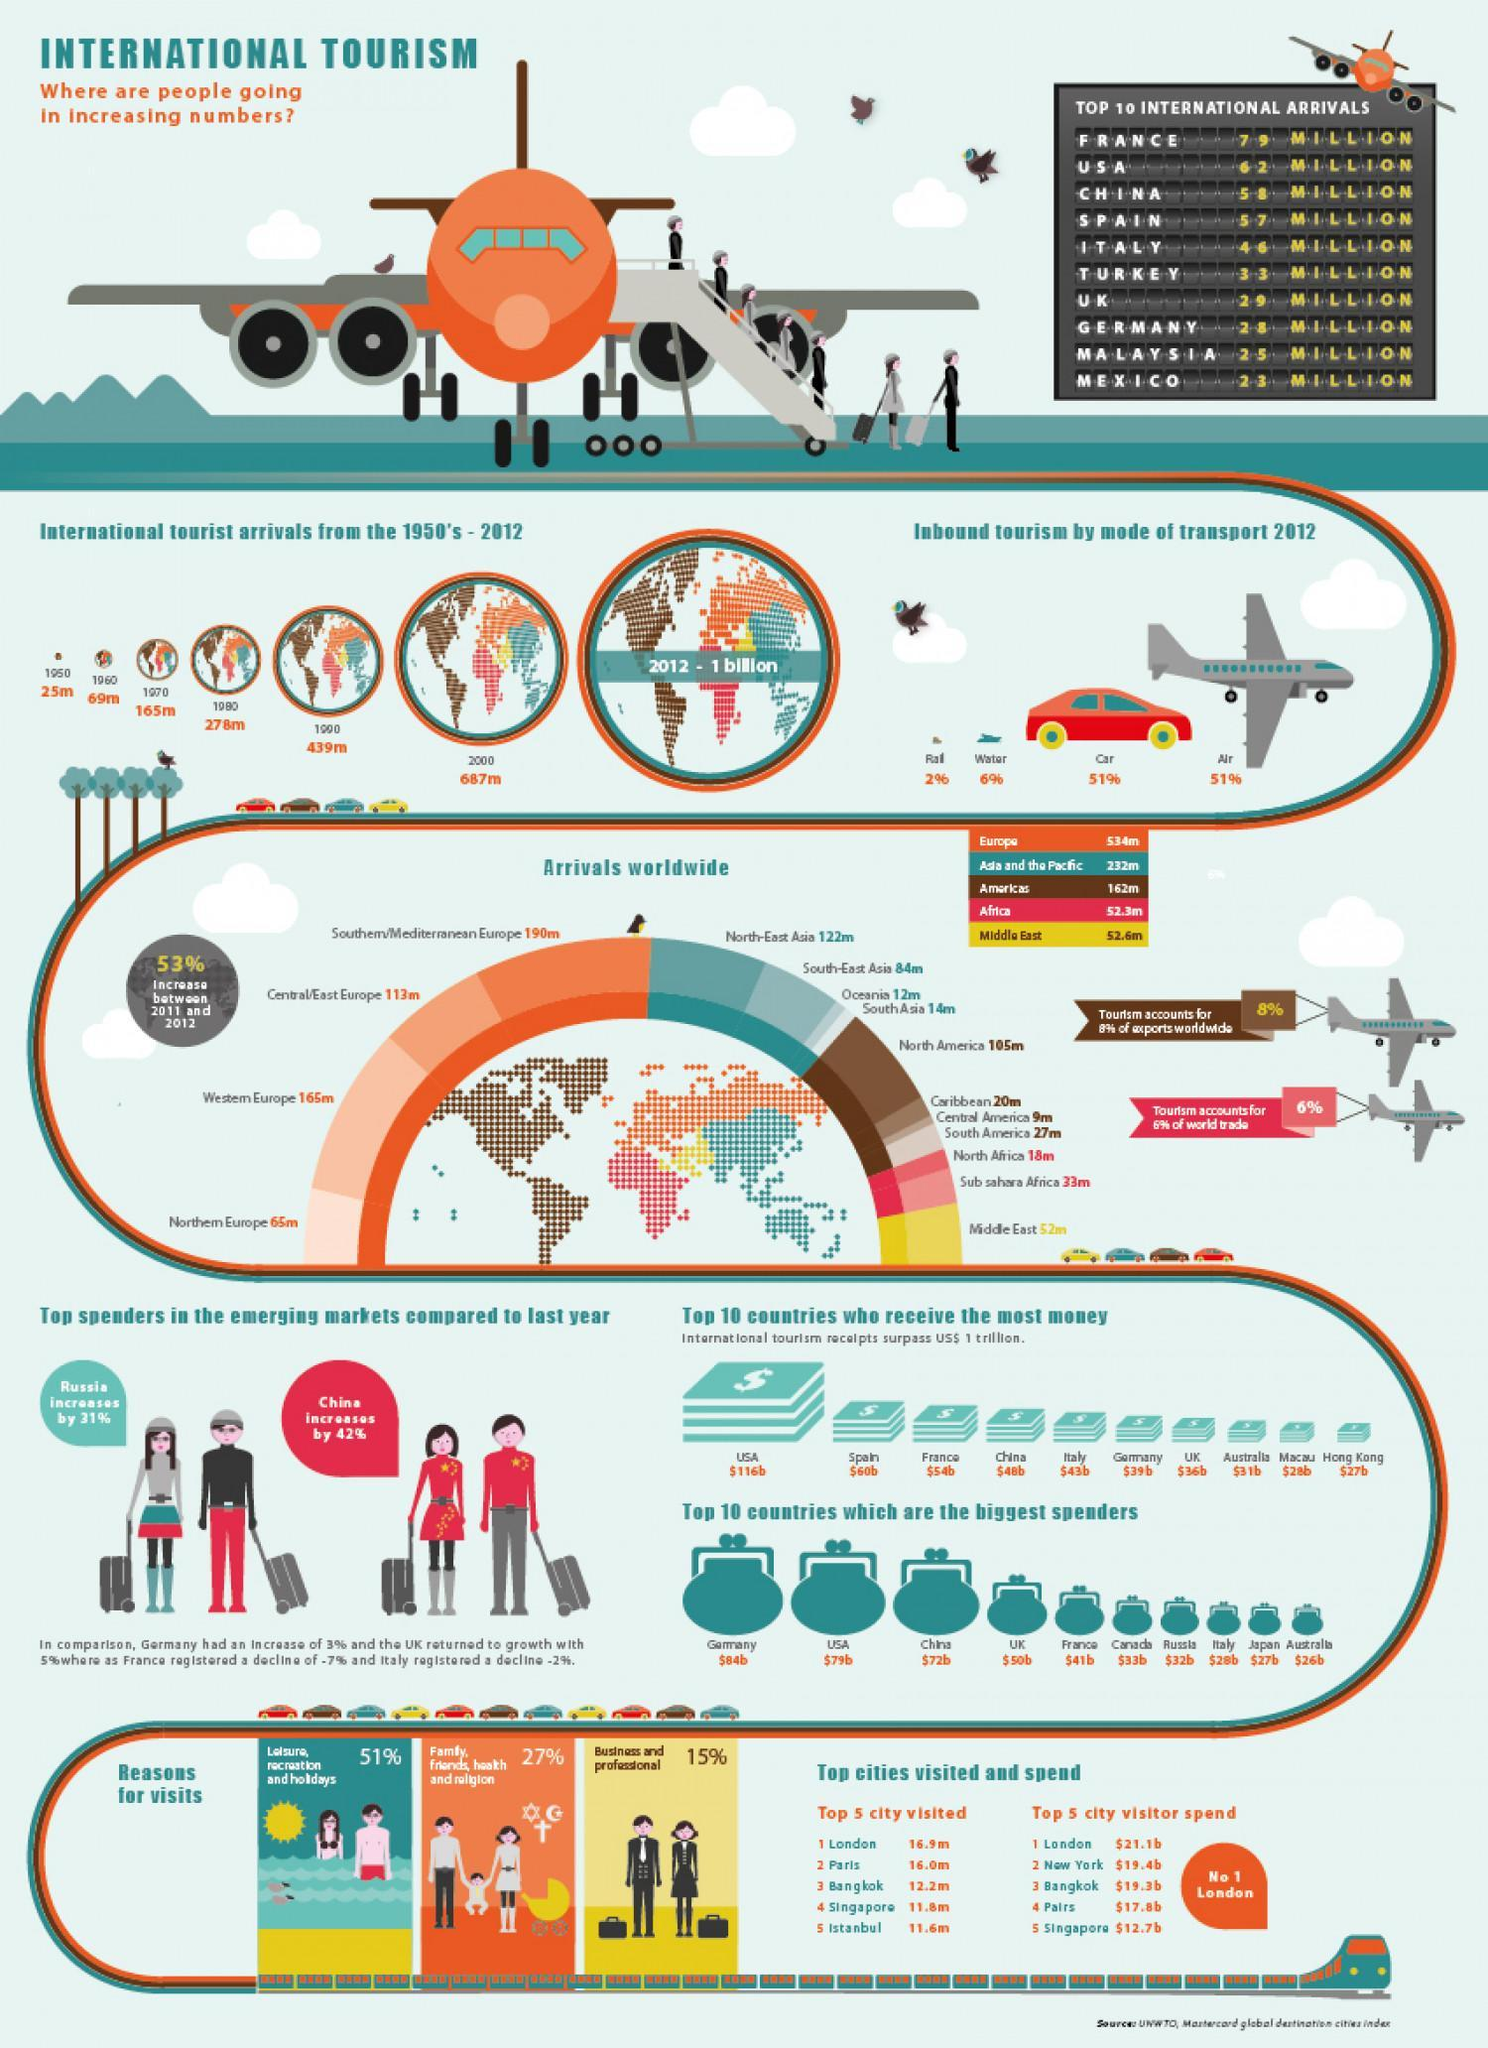What is the percentage of inbound tourism by mode of car and water transport, taken together?
Answer the question with a short phrase. 57% What is the percentage of inbound tourism by mode of air and rail transport, taken together? 53% What is the percentage of arrivals in South Asia and the Caribbean, taken together? 34m What is the number of international tourist arrivals in 1970 and 1980, taken together? 443m What is the number of international tourist arrivals in 1950 and 1960, taken together? 94m 